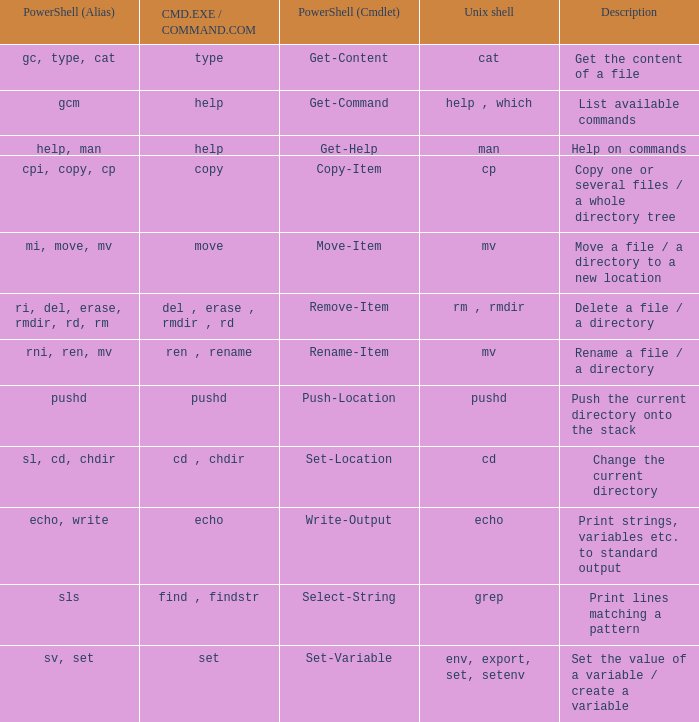What are all values of CMD.EXE / COMMAND.COM for the unix shell echo? Echo. 